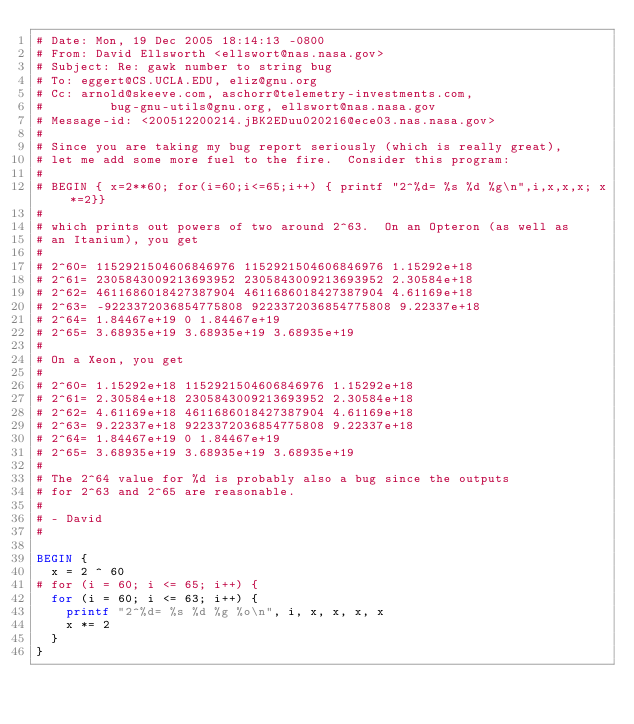Convert code to text. <code><loc_0><loc_0><loc_500><loc_500><_Awk_># Date: Mon, 19 Dec 2005 18:14:13 -0800
# From: David Ellsworth <ellswort@nas.nasa.gov>
# Subject: Re: gawk number to string bug
# To: eggert@CS.UCLA.EDU, eliz@gnu.org
# Cc: arnold@skeeve.com, aschorr@telemetry-investments.com,
#         bug-gnu-utils@gnu.org, ellswort@nas.nasa.gov
# Message-id: <200512200214.jBK2EDuu020216@ece03.nas.nasa.gov>
# 
# Since you are taking my bug report seriously (which is really great),
# let me add some more fuel to the fire.  Consider this program:
# 
# BEGIN { x=2**60; for(i=60;i<=65;i++) { printf "2^%d= %s %d %g\n",i,x,x,x; x*=2}}
# 
# which prints out powers of two around 2^63.  On an Opteron (as well as
# an Itanium), you get
# 
# 2^60= 1152921504606846976 1152921504606846976 1.15292e+18
# 2^61= 2305843009213693952 2305843009213693952 2.30584e+18
# 2^62= 4611686018427387904 4611686018427387904 4.61169e+18
# 2^63= -9223372036854775808 9223372036854775808 9.22337e+18
# 2^64= 1.84467e+19 0 1.84467e+19
# 2^65= 3.68935e+19 3.68935e+19 3.68935e+19
# 
# On a Xeon, you get
# 
# 2^60= 1.15292e+18 1152921504606846976 1.15292e+18
# 2^61= 2.30584e+18 2305843009213693952 2.30584e+18
# 2^62= 4.61169e+18 4611686018427387904 4.61169e+18
# 2^63= 9.22337e+18 9223372036854775808 9.22337e+18
# 2^64= 1.84467e+19 0 1.84467e+19
# 2^65= 3.68935e+19 3.68935e+19 3.68935e+19
# 
# The 2^64 value for %d is probably also a bug since the outputs
# for 2^63 and 2^65 are reasonable.
# 
# - David
# 

BEGIN {
	x = 2 ^ 60
#	for (i = 60; i <= 65; i++) {
	for (i = 60; i <= 63; i++) {
		printf "2^%d= %s %d %g %o\n", i, x, x, x, x
		x *= 2
	}
}
</code> 